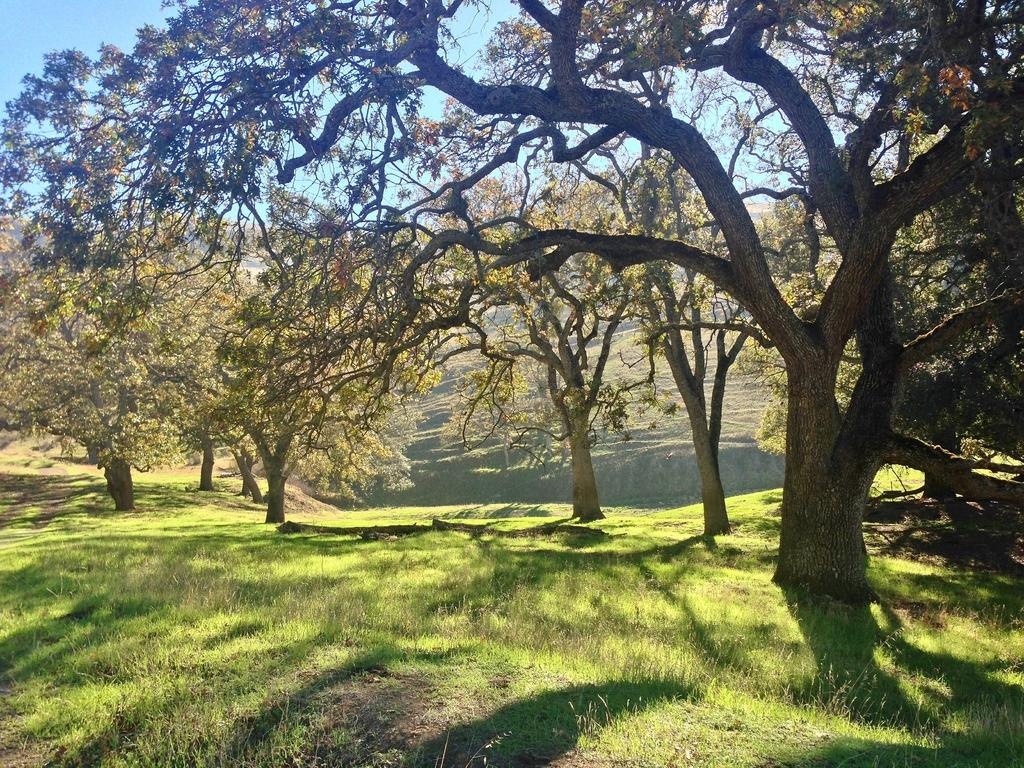What type of vegetation can be seen in the image? There are trees in the image. What is present at the bottom of the image? There is grass at the bottom of the image. What type of soda can be heard being poured in the image? There is no soda or sound of pouring present in the image; it only features trees and grass. What journey is depicted in the image? There is no journey depicted in the image; it simply shows trees and grass. 